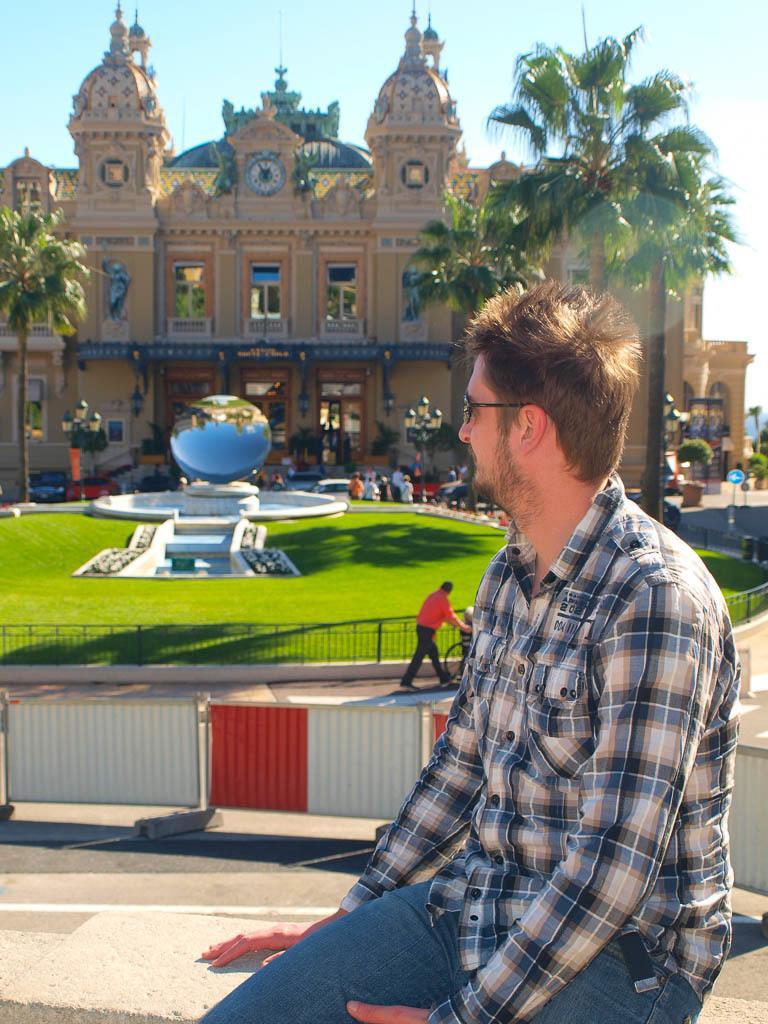In one or two sentences, can you explain what this image depicts? In this picture I can see a man sitting, there are group of people, there is a kind of fountain, there is a clock, there are lights, poles, there is a building, there are trees, and in the background there is sky. 